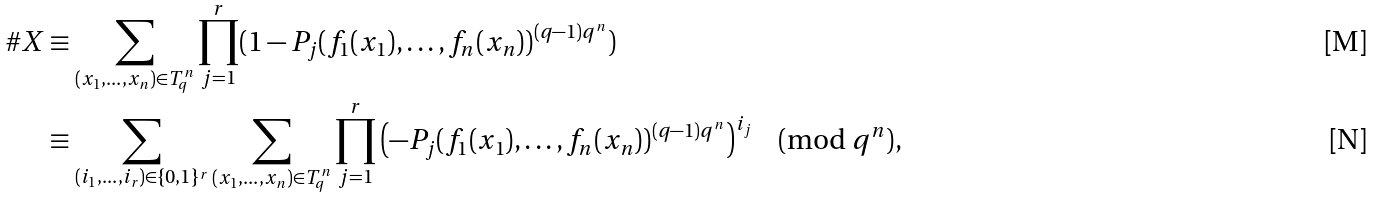Convert formula to latex. <formula><loc_0><loc_0><loc_500><loc_500>\# X & \equiv \sum _ { ( x _ { 1 } , \dots , x _ { n } ) \in T _ { q } ^ { n } } \prod _ { j = 1 } ^ { r } ( 1 - P _ { j } ( f _ { 1 } ( x _ { 1 } ) , \dots , f _ { n } ( x _ { n } ) ) ^ { ( q - 1 ) q ^ { n } } ) \\ & \equiv \sum _ { ( i _ { 1 } , \dots , i _ { r } ) \in \{ 0 , 1 \} ^ { r } } \sum _ { ( x _ { 1 } , \dots , x _ { n } ) \in T _ { q } ^ { n } } \prod _ { j = 1 } ^ { r } \left ( - P _ { j } ( f _ { 1 } ( x _ { 1 } ) , \dots , f _ { n } ( x _ { n } ) ) ^ { ( q - 1 ) q ^ { n } } \right ) ^ { i _ { j } } \, \pmod { q ^ { n } } ,</formula> 